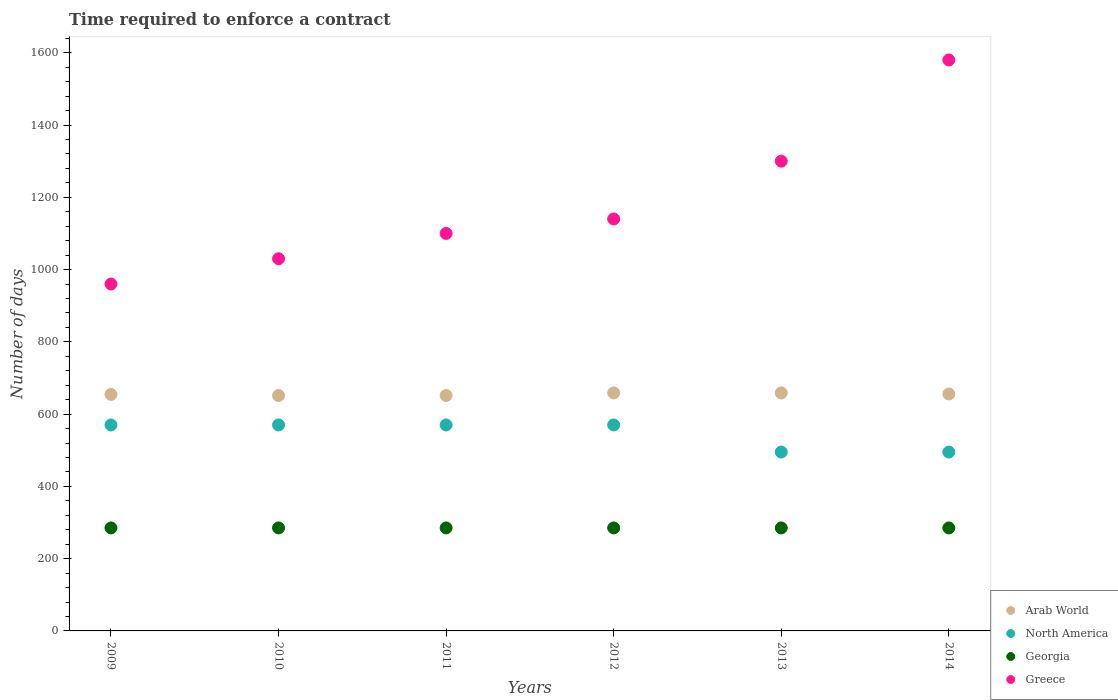What is the number of days required to enforce a contract in Greece in 2011?
Your answer should be very brief. 1100. Across all years, what is the maximum number of days required to enforce a contract in Georgia?
Keep it short and to the point. 285. Across all years, what is the minimum number of days required to enforce a contract in Greece?
Provide a succinct answer. 960. In which year was the number of days required to enforce a contract in Greece maximum?
Provide a short and direct response. 2014. What is the total number of days required to enforce a contract in Georgia in the graph?
Your response must be concise. 1710. What is the difference between the number of days required to enforce a contract in North America in 2011 and that in 2012?
Provide a succinct answer. 0. What is the difference between the number of days required to enforce a contract in Georgia in 2014 and the number of days required to enforce a contract in North America in 2010?
Your answer should be very brief. -285. What is the average number of days required to enforce a contract in Georgia per year?
Offer a very short reply. 285. In the year 2013, what is the difference between the number of days required to enforce a contract in Arab World and number of days required to enforce a contract in North America?
Make the answer very short. 163.62. What is the ratio of the number of days required to enforce a contract in Georgia in 2011 to that in 2013?
Your response must be concise. 1. Is the number of days required to enforce a contract in North America in 2009 less than that in 2013?
Make the answer very short. No. Is the difference between the number of days required to enforce a contract in Arab World in 2009 and 2011 greater than the difference between the number of days required to enforce a contract in North America in 2009 and 2011?
Ensure brevity in your answer.  Yes. What is the difference between the highest and the second highest number of days required to enforce a contract in Georgia?
Your answer should be very brief. 0. What is the difference between the highest and the lowest number of days required to enforce a contract in Greece?
Offer a very short reply. 620. Is the sum of the number of days required to enforce a contract in Georgia in 2009 and 2013 greater than the maximum number of days required to enforce a contract in Greece across all years?
Keep it short and to the point. No. Is it the case that in every year, the sum of the number of days required to enforce a contract in Greece and number of days required to enforce a contract in Arab World  is greater than the sum of number of days required to enforce a contract in North America and number of days required to enforce a contract in Georgia?
Your answer should be very brief. Yes. Is it the case that in every year, the sum of the number of days required to enforce a contract in Georgia and number of days required to enforce a contract in North America  is greater than the number of days required to enforce a contract in Arab World?
Keep it short and to the point. Yes. How many years are there in the graph?
Keep it short and to the point. 6. What is the difference between two consecutive major ticks on the Y-axis?
Keep it short and to the point. 200. Are the values on the major ticks of Y-axis written in scientific E-notation?
Give a very brief answer. No. Does the graph contain grids?
Give a very brief answer. No. Where does the legend appear in the graph?
Make the answer very short. Bottom right. How many legend labels are there?
Give a very brief answer. 4. What is the title of the graph?
Give a very brief answer. Time required to enforce a contract. What is the label or title of the X-axis?
Offer a terse response. Years. What is the label or title of the Y-axis?
Your answer should be compact. Number of days. What is the Number of days of Arab World in 2009?
Offer a terse response. 654.45. What is the Number of days of North America in 2009?
Give a very brief answer. 570. What is the Number of days in Georgia in 2009?
Provide a succinct answer. 285. What is the Number of days of Greece in 2009?
Make the answer very short. 960. What is the Number of days in Arab World in 2010?
Provide a short and direct response. 651.45. What is the Number of days of North America in 2010?
Keep it short and to the point. 570. What is the Number of days of Georgia in 2010?
Provide a short and direct response. 285. What is the Number of days of Greece in 2010?
Ensure brevity in your answer.  1030. What is the Number of days of Arab World in 2011?
Your response must be concise. 651.45. What is the Number of days of North America in 2011?
Give a very brief answer. 570. What is the Number of days of Georgia in 2011?
Offer a very short reply. 285. What is the Number of days of Greece in 2011?
Provide a short and direct response. 1100. What is the Number of days of Arab World in 2012?
Provide a succinct answer. 658.62. What is the Number of days of North America in 2012?
Provide a short and direct response. 570. What is the Number of days of Georgia in 2012?
Your answer should be compact. 285. What is the Number of days in Greece in 2012?
Your answer should be compact. 1140. What is the Number of days in Arab World in 2013?
Your answer should be compact. 658.62. What is the Number of days of North America in 2013?
Give a very brief answer. 495. What is the Number of days in Georgia in 2013?
Keep it short and to the point. 285. What is the Number of days of Greece in 2013?
Offer a very short reply. 1300. What is the Number of days in Arab World in 2014?
Ensure brevity in your answer.  655.76. What is the Number of days in North America in 2014?
Provide a short and direct response. 495. What is the Number of days in Georgia in 2014?
Your answer should be very brief. 285. What is the Number of days in Greece in 2014?
Offer a very short reply. 1580. Across all years, what is the maximum Number of days of Arab World?
Provide a succinct answer. 658.62. Across all years, what is the maximum Number of days of North America?
Your response must be concise. 570. Across all years, what is the maximum Number of days of Georgia?
Your answer should be compact. 285. Across all years, what is the maximum Number of days of Greece?
Ensure brevity in your answer.  1580. Across all years, what is the minimum Number of days in Arab World?
Offer a terse response. 651.45. Across all years, what is the minimum Number of days of North America?
Give a very brief answer. 495. Across all years, what is the minimum Number of days of Georgia?
Offer a terse response. 285. Across all years, what is the minimum Number of days in Greece?
Offer a very short reply. 960. What is the total Number of days in Arab World in the graph?
Your response must be concise. 3930.35. What is the total Number of days in North America in the graph?
Your answer should be very brief. 3270. What is the total Number of days in Georgia in the graph?
Your answer should be compact. 1710. What is the total Number of days in Greece in the graph?
Your answer should be compact. 7110. What is the difference between the Number of days of Georgia in 2009 and that in 2010?
Ensure brevity in your answer.  0. What is the difference between the Number of days in Greece in 2009 and that in 2010?
Keep it short and to the point. -70. What is the difference between the Number of days in Arab World in 2009 and that in 2011?
Offer a terse response. 3. What is the difference between the Number of days in North America in 2009 and that in 2011?
Your answer should be compact. 0. What is the difference between the Number of days of Greece in 2009 and that in 2011?
Provide a succinct answer. -140. What is the difference between the Number of days of Arab World in 2009 and that in 2012?
Provide a short and direct response. -4.17. What is the difference between the Number of days of North America in 2009 and that in 2012?
Provide a short and direct response. 0. What is the difference between the Number of days in Georgia in 2009 and that in 2012?
Provide a succinct answer. 0. What is the difference between the Number of days of Greece in 2009 and that in 2012?
Your answer should be very brief. -180. What is the difference between the Number of days in Arab World in 2009 and that in 2013?
Your response must be concise. -4.17. What is the difference between the Number of days in Georgia in 2009 and that in 2013?
Your answer should be compact. 0. What is the difference between the Number of days of Greece in 2009 and that in 2013?
Give a very brief answer. -340. What is the difference between the Number of days of Arab World in 2009 and that in 2014?
Your answer should be compact. -1.31. What is the difference between the Number of days in Georgia in 2009 and that in 2014?
Provide a succinct answer. 0. What is the difference between the Number of days in Greece in 2009 and that in 2014?
Make the answer very short. -620. What is the difference between the Number of days of Greece in 2010 and that in 2011?
Your response must be concise. -70. What is the difference between the Number of days of Arab World in 2010 and that in 2012?
Offer a terse response. -7.17. What is the difference between the Number of days of Georgia in 2010 and that in 2012?
Your response must be concise. 0. What is the difference between the Number of days of Greece in 2010 and that in 2012?
Provide a short and direct response. -110. What is the difference between the Number of days in Arab World in 2010 and that in 2013?
Your answer should be very brief. -7.17. What is the difference between the Number of days of North America in 2010 and that in 2013?
Make the answer very short. 75. What is the difference between the Number of days of Greece in 2010 and that in 2013?
Your response must be concise. -270. What is the difference between the Number of days in Arab World in 2010 and that in 2014?
Your answer should be very brief. -4.31. What is the difference between the Number of days in North America in 2010 and that in 2014?
Keep it short and to the point. 75. What is the difference between the Number of days of Greece in 2010 and that in 2014?
Ensure brevity in your answer.  -550. What is the difference between the Number of days in Arab World in 2011 and that in 2012?
Keep it short and to the point. -7.17. What is the difference between the Number of days in Greece in 2011 and that in 2012?
Offer a terse response. -40. What is the difference between the Number of days of Arab World in 2011 and that in 2013?
Give a very brief answer. -7.17. What is the difference between the Number of days of North America in 2011 and that in 2013?
Keep it short and to the point. 75. What is the difference between the Number of days of Georgia in 2011 and that in 2013?
Your answer should be compact. 0. What is the difference between the Number of days in Greece in 2011 and that in 2013?
Provide a short and direct response. -200. What is the difference between the Number of days of Arab World in 2011 and that in 2014?
Provide a short and direct response. -4.31. What is the difference between the Number of days of Greece in 2011 and that in 2014?
Keep it short and to the point. -480. What is the difference between the Number of days of North America in 2012 and that in 2013?
Keep it short and to the point. 75. What is the difference between the Number of days of Greece in 2012 and that in 2013?
Provide a succinct answer. -160. What is the difference between the Number of days of Arab World in 2012 and that in 2014?
Provide a succinct answer. 2.86. What is the difference between the Number of days of North America in 2012 and that in 2014?
Provide a short and direct response. 75. What is the difference between the Number of days of Greece in 2012 and that in 2014?
Offer a very short reply. -440. What is the difference between the Number of days in Arab World in 2013 and that in 2014?
Offer a very short reply. 2.86. What is the difference between the Number of days of North America in 2013 and that in 2014?
Ensure brevity in your answer.  0. What is the difference between the Number of days of Georgia in 2013 and that in 2014?
Make the answer very short. 0. What is the difference between the Number of days in Greece in 2013 and that in 2014?
Give a very brief answer. -280. What is the difference between the Number of days of Arab World in 2009 and the Number of days of North America in 2010?
Keep it short and to the point. 84.45. What is the difference between the Number of days in Arab World in 2009 and the Number of days in Georgia in 2010?
Offer a terse response. 369.45. What is the difference between the Number of days in Arab World in 2009 and the Number of days in Greece in 2010?
Make the answer very short. -375.55. What is the difference between the Number of days in North America in 2009 and the Number of days in Georgia in 2010?
Your response must be concise. 285. What is the difference between the Number of days of North America in 2009 and the Number of days of Greece in 2010?
Your response must be concise. -460. What is the difference between the Number of days in Georgia in 2009 and the Number of days in Greece in 2010?
Offer a terse response. -745. What is the difference between the Number of days in Arab World in 2009 and the Number of days in North America in 2011?
Give a very brief answer. 84.45. What is the difference between the Number of days in Arab World in 2009 and the Number of days in Georgia in 2011?
Your answer should be very brief. 369.45. What is the difference between the Number of days of Arab World in 2009 and the Number of days of Greece in 2011?
Provide a short and direct response. -445.55. What is the difference between the Number of days of North America in 2009 and the Number of days of Georgia in 2011?
Offer a very short reply. 285. What is the difference between the Number of days in North America in 2009 and the Number of days in Greece in 2011?
Your answer should be compact. -530. What is the difference between the Number of days of Georgia in 2009 and the Number of days of Greece in 2011?
Offer a very short reply. -815. What is the difference between the Number of days in Arab World in 2009 and the Number of days in North America in 2012?
Your answer should be compact. 84.45. What is the difference between the Number of days of Arab World in 2009 and the Number of days of Georgia in 2012?
Make the answer very short. 369.45. What is the difference between the Number of days in Arab World in 2009 and the Number of days in Greece in 2012?
Ensure brevity in your answer.  -485.55. What is the difference between the Number of days of North America in 2009 and the Number of days of Georgia in 2012?
Offer a very short reply. 285. What is the difference between the Number of days of North America in 2009 and the Number of days of Greece in 2012?
Ensure brevity in your answer.  -570. What is the difference between the Number of days of Georgia in 2009 and the Number of days of Greece in 2012?
Your answer should be very brief. -855. What is the difference between the Number of days in Arab World in 2009 and the Number of days in North America in 2013?
Offer a very short reply. 159.45. What is the difference between the Number of days of Arab World in 2009 and the Number of days of Georgia in 2013?
Provide a short and direct response. 369.45. What is the difference between the Number of days of Arab World in 2009 and the Number of days of Greece in 2013?
Offer a terse response. -645.55. What is the difference between the Number of days in North America in 2009 and the Number of days in Georgia in 2013?
Your answer should be very brief. 285. What is the difference between the Number of days in North America in 2009 and the Number of days in Greece in 2013?
Provide a succinct answer. -730. What is the difference between the Number of days of Georgia in 2009 and the Number of days of Greece in 2013?
Offer a terse response. -1015. What is the difference between the Number of days in Arab World in 2009 and the Number of days in North America in 2014?
Offer a very short reply. 159.45. What is the difference between the Number of days in Arab World in 2009 and the Number of days in Georgia in 2014?
Keep it short and to the point. 369.45. What is the difference between the Number of days of Arab World in 2009 and the Number of days of Greece in 2014?
Provide a short and direct response. -925.55. What is the difference between the Number of days of North America in 2009 and the Number of days of Georgia in 2014?
Offer a terse response. 285. What is the difference between the Number of days in North America in 2009 and the Number of days in Greece in 2014?
Your answer should be compact. -1010. What is the difference between the Number of days in Georgia in 2009 and the Number of days in Greece in 2014?
Your answer should be compact. -1295. What is the difference between the Number of days of Arab World in 2010 and the Number of days of North America in 2011?
Offer a very short reply. 81.45. What is the difference between the Number of days in Arab World in 2010 and the Number of days in Georgia in 2011?
Keep it short and to the point. 366.45. What is the difference between the Number of days in Arab World in 2010 and the Number of days in Greece in 2011?
Offer a terse response. -448.55. What is the difference between the Number of days of North America in 2010 and the Number of days of Georgia in 2011?
Give a very brief answer. 285. What is the difference between the Number of days in North America in 2010 and the Number of days in Greece in 2011?
Your answer should be compact. -530. What is the difference between the Number of days in Georgia in 2010 and the Number of days in Greece in 2011?
Your response must be concise. -815. What is the difference between the Number of days in Arab World in 2010 and the Number of days in North America in 2012?
Your answer should be very brief. 81.45. What is the difference between the Number of days of Arab World in 2010 and the Number of days of Georgia in 2012?
Your response must be concise. 366.45. What is the difference between the Number of days in Arab World in 2010 and the Number of days in Greece in 2012?
Give a very brief answer. -488.55. What is the difference between the Number of days of North America in 2010 and the Number of days of Georgia in 2012?
Offer a very short reply. 285. What is the difference between the Number of days of North America in 2010 and the Number of days of Greece in 2012?
Keep it short and to the point. -570. What is the difference between the Number of days in Georgia in 2010 and the Number of days in Greece in 2012?
Your answer should be compact. -855. What is the difference between the Number of days of Arab World in 2010 and the Number of days of North America in 2013?
Give a very brief answer. 156.45. What is the difference between the Number of days in Arab World in 2010 and the Number of days in Georgia in 2013?
Provide a succinct answer. 366.45. What is the difference between the Number of days in Arab World in 2010 and the Number of days in Greece in 2013?
Provide a succinct answer. -648.55. What is the difference between the Number of days of North America in 2010 and the Number of days of Georgia in 2013?
Offer a terse response. 285. What is the difference between the Number of days in North America in 2010 and the Number of days in Greece in 2013?
Keep it short and to the point. -730. What is the difference between the Number of days in Georgia in 2010 and the Number of days in Greece in 2013?
Your answer should be compact. -1015. What is the difference between the Number of days in Arab World in 2010 and the Number of days in North America in 2014?
Offer a terse response. 156.45. What is the difference between the Number of days of Arab World in 2010 and the Number of days of Georgia in 2014?
Your answer should be compact. 366.45. What is the difference between the Number of days in Arab World in 2010 and the Number of days in Greece in 2014?
Keep it short and to the point. -928.55. What is the difference between the Number of days in North America in 2010 and the Number of days in Georgia in 2014?
Give a very brief answer. 285. What is the difference between the Number of days in North America in 2010 and the Number of days in Greece in 2014?
Offer a terse response. -1010. What is the difference between the Number of days of Georgia in 2010 and the Number of days of Greece in 2014?
Keep it short and to the point. -1295. What is the difference between the Number of days in Arab World in 2011 and the Number of days in North America in 2012?
Your answer should be very brief. 81.45. What is the difference between the Number of days in Arab World in 2011 and the Number of days in Georgia in 2012?
Offer a very short reply. 366.45. What is the difference between the Number of days in Arab World in 2011 and the Number of days in Greece in 2012?
Your answer should be compact. -488.55. What is the difference between the Number of days of North America in 2011 and the Number of days of Georgia in 2012?
Your answer should be very brief. 285. What is the difference between the Number of days in North America in 2011 and the Number of days in Greece in 2012?
Ensure brevity in your answer.  -570. What is the difference between the Number of days in Georgia in 2011 and the Number of days in Greece in 2012?
Provide a short and direct response. -855. What is the difference between the Number of days in Arab World in 2011 and the Number of days in North America in 2013?
Make the answer very short. 156.45. What is the difference between the Number of days in Arab World in 2011 and the Number of days in Georgia in 2013?
Your response must be concise. 366.45. What is the difference between the Number of days in Arab World in 2011 and the Number of days in Greece in 2013?
Your answer should be very brief. -648.55. What is the difference between the Number of days of North America in 2011 and the Number of days of Georgia in 2013?
Your answer should be compact. 285. What is the difference between the Number of days of North America in 2011 and the Number of days of Greece in 2013?
Provide a short and direct response. -730. What is the difference between the Number of days in Georgia in 2011 and the Number of days in Greece in 2013?
Ensure brevity in your answer.  -1015. What is the difference between the Number of days in Arab World in 2011 and the Number of days in North America in 2014?
Make the answer very short. 156.45. What is the difference between the Number of days of Arab World in 2011 and the Number of days of Georgia in 2014?
Provide a short and direct response. 366.45. What is the difference between the Number of days of Arab World in 2011 and the Number of days of Greece in 2014?
Offer a terse response. -928.55. What is the difference between the Number of days of North America in 2011 and the Number of days of Georgia in 2014?
Keep it short and to the point. 285. What is the difference between the Number of days of North America in 2011 and the Number of days of Greece in 2014?
Your response must be concise. -1010. What is the difference between the Number of days of Georgia in 2011 and the Number of days of Greece in 2014?
Ensure brevity in your answer.  -1295. What is the difference between the Number of days of Arab World in 2012 and the Number of days of North America in 2013?
Give a very brief answer. 163.62. What is the difference between the Number of days of Arab World in 2012 and the Number of days of Georgia in 2013?
Your response must be concise. 373.62. What is the difference between the Number of days of Arab World in 2012 and the Number of days of Greece in 2013?
Your response must be concise. -641.38. What is the difference between the Number of days in North America in 2012 and the Number of days in Georgia in 2013?
Give a very brief answer. 285. What is the difference between the Number of days of North America in 2012 and the Number of days of Greece in 2013?
Offer a terse response. -730. What is the difference between the Number of days in Georgia in 2012 and the Number of days in Greece in 2013?
Offer a terse response. -1015. What is the difference between the Number of days of Arab World in 2012 and the Number of days of North America in 2014?
Offer a terse response. 163.62. What is the difference between the Number of days of Arab World in 2012 and the Number of days of Georgia in 2014?
Provide a succinct answer. 373.62. What is the difference between the Number of days of Arab World in 2012 and the Number of days of Greece in 2014?
Offer a terse response. -921.38. What is the difference between the Number of days of North America in 2012 and the Number of days of Georgia in 2014?
Ensure brevity in your answer.  285. What is the difference between the Number of days in North America in 2012 and the Number of days in Greece in 2014?
Your response must be concise. -1010. What is the difference between the Number of days of Georgia in 2012 and the Number of days of Greece in 2014?
Your response must be concise. -1295. What is the difference between the Number of days in Arab World in 2013 and the Number of days in North America in 2014?
Ensure brevity in your answer.  163.62. What is the difference between the Number of days in Arab World in 2013 and the Number of days in Georgia in 2014?
Your response must be concise. 373.62. What is the difference between the Number of days of Arab World in 2013 and the Number of days of Greece in 2014?
Provide a succinct answer. -921.38. What is the difference between the Number of days of North America in 2013 and the Number of days of Georgia in 2014?
Offer a terse response. 210. What is the difference between the Number of days in North America in 2013 and the Number of days in Greece in 2014?
Offer a terse response. -1085. What is the difference between the Number of days of Georgia in 2013 and the Number of days of Greece in 2014?
Provide a succinct answer. -1295. What is the average Number of days of Arab World per year?
Provide a short and direct response. 655.06. What is the average Number of days of North America per year?
Make the answer very short. 545. What is the average Number of days of Georgia per year?
Your answer should be compact. 285. What is the average Number of days in Greece per year?
Provide a succinct answer. 1185. In the year 2009, what is the difference between the Number of days in Arab World and Number of days in North America?
Your answer should be compact. 84.45. In the year 2009, what is the difference between the Number of days in Arab World and Number of days in Georgia?
Your answer should be compact. 369.45. In the year 2009, what is the difference between the Number of days in Arab World and Number of days in Greece?
Provide a short and direct response. -305.55. In the year 2009, what is the difference between the Number of days of North America and Number of days of Georgia?
Ensure brevity in your answer.  285. In the year 2009, what is the difference between the Number of days of North America and Number of days of Greece?
Your response must be concise. -390. In the year 2009, what is the difference between the Number of days of Georgia and Number of days of Greece?
Ensure brevity in your answer.  -675. In the year 2010, what is the difference between the Number of days in Arab World and Number of days in North America?
Provide a short and direct response. 81.45. In the year 2010, what is the difference between the Number of days in Arab World and Number of days in Georgia?
Provide a short and direct response. 366.45. In the year 2010, what is the difference between the Number of days of Arab World and Number of days of Greece?
Give a very brief answer. -378.55. In the year 2010, what is the difference between the Number of days in North America and Number of days in Georgia?
Provide a short and direct response. 285. In the year 2010, what is the difference between the Number of days of North America and Number of days of Greece?
Provide a succinct answer. -460. In the year 2010, what is the difference between the Number of days in Georgia and Number of days in Greece?
Ensure brevity in your answer.  -745. In the year 2011, what is the difference between the Number of days in Arab World and Number of days in North America?
Make the answer very short. 81.45. In the year 2011, what is the difference between the Number of days of Arab World and Number of days of Georgia?
Offer a terse response. 366.45. In the year 2011, what is the difference between the Number of days in Arab World and Number of days in Greece?
Give a very brief answer. -448.55. In the year 2011, what is the difference between the Number of days of North America and Number of days of Georgia?
Offer a very short reply. 285. In the year 2011, what is the difference between the Number of days in North America and Number of days in Greece?
Your response must be concise. -530. In the year 2011, what is the difference between the Number of days of Georgia and Number of days of Greece?
Keep it short and to the point. -815. In the year 2012, what is the difference between the Number of days in Arab World and Number of days in North America?
Your answer should be compact. 88.62. In the year 2012, what is the difference between the Number of days in Arab World and Number of days in Georgia?
Your answer should be compact. 373.62. In the year 2012, what is the difference between the Number of days in Arab World and Number of days in Greece?
Keep it short and to the point. -481.38. In the year 2012, what is the difference between the Number of days in North America and Number of days in Georgia?
Provide a succinct answer. 285. In the year 2012, what is the difference between the Number of days in North America and Number of days in Greece?
Provide a short and direct response. -570. In the year 2012, what is the difference between the Number of days in Georgia and Number of days in Greece?
Your answer should be compact. -855. In the year 2013, what is the difference between the Number of days in Arab World and Number of days in North America?
Give a very brief answer. 163.62. In the year 2013, what is the difference between the Number of days in Arab World and Number of days in Georgia?
Make the answer very short. 373.62. In the year 2013, what is the difference between the Number of days in Arab World and Number of days in Greece?
Your response must be concise. -641.38. In the year 2013, what is the difference between the Number of days in North America and Number of days in Georgia?
Give a very brief answer. 210. In the year 2013, what is the difference between the Number of days of North America and Number of days of Greece?
Provide a short and direct response. -805. In the year 2013, what is the difference between the Number of days of Georgia and Number of days of Greece?
Give a very brief answer. -1015. In the year 2014, what is the difference between the Number of days in Arab World and Number of days in North America?
Your response must be concise. 160.76. In the year 2014, what is the difference between the Number of days of Arab World and Number of days of Georgia?
Keep it short and to the point. 370.76. In the year 2014, what is the difference between the Number of days in Arab World and Number of days in Greece?
Provide a succinct answer. -924.24. In the year 2014, what is the difference between the Number of days in North America and Number of days in Georgia?
Provide a short and direct response. 210. In the year 2014, what is the difference between the Number of days of North America and Number of days of Greece?
Offer a very short reply. -1085. In the year 2014, what is the difference between the Number of days of Georgia and Number of days of Greece?
Keep it short and to the point. -1295. What is the ratio of the Number of days in Arab World in 2009 to that in 2010?
Your answer should be compact. 1. What is the ratio of the Number of days of North America in 2009 to that in 2010?
Make the answer very short. 1. What is the ratio of the Number of days of Greece in 2009 to that in 2010?
Ensure brevity in your answer.  0.93. What is the ratio of the Number of days of Greece in 2009 to that in 2011?
Your answer should be very brief. 0.87. What is the ratio of the Number of days of North America in 2009 to that in 2012?
Give a very brief answer. 1. What is the ratio of the Number of days of Greece in 2009 to that in 2012?
Provide a succinct answer. 0.84. What is the ratio of the Number of days in North America in 2009 to that in 2013?
Your response must be concise. 1.15. What is the ratio of the Number of days in Georgia in 2009 to that in 2013?
Provide a short and direct response. 1. What is the ratio of the Number of days of Greece in 2009 to that in 2013?
Your answer should be very brief. 0.74. What is the ratio of the Number of days of Arab World in 2009 to that in 2014?
Ensure brevity in your answer.  1. What is the ratio of the Number of days of North America in 2009 to that in 2014?
Keep it short and to the point. 1.15. What is the ratio of the Number of days of Georgia in 2009 to that in 2014?
Your answer should be compact. 1. What is the ratio of the Number of days in Greece in 2009 to that in 2014?
Keep it short and to the point. 0.61. What is the ratio of the Number of days in Arab World in 2010 to that in 2011?
Ensure brevity in your answer.  1. What is the ratio of the Number of days in North America in 2010 to that in 2011?
Provide a short and direct response. 1. What is the ratio of the Number of days of Georgia in 2010 to that in 2011?
Offer a very short reply. 1. What is the ratio of the Number of days in Greece in 2010 to that in 2011?
Your answer should be very brief. 0.94. What is the ratio of the Number of days of Greece in 2010 to that in 2012?
Ensure brevity in your answer.  0.9. What is the ratio of the Number of days in Arab World in 2010 to that in 2013?
Ensure brevity in your answer.  0.99. What is the ratio of the Number of days in North America in 2010 to that in 2013?
Your response must be concise. 1.15. What is the ratio of the Number of days of Georgia in 2010 to that in 2013?
Keep it short and to the point. 1. What is the ratio of the Number of days in Greece in 2010 to that in 2013?
Provide a succinct answer. 0.79. What is the ratio of the Number of days of Arab World in 2010 to that in 2014?
Keep it short and to the point. 0.99. What is the ratio of the Number of days of North America in 2010 to that in 2014?
Provide a short and direct response. 1.15. What is the ratio of the Number of days in Georgia in 2010 to that in 2014?
Make the answer very short. 1. What is the ratio of the Number of days in Greece in 2010 to that in 2014?
Offer a terse response. 0.65. What is the ratio of the Number of days of North America in 2011 to that in 2012?
Your answer should be compact. 1. What is the ratio of the Number of days of Greece in 2011 to that in 2012?
Provide a succinct answer. 0.96. What is the ratio of the Number of days of Arab World in 2011 to that in 2013?
Your answer should be compact. 0.99. What is the ratio of the Number of days of North America in 2011 to that in 2013?
Provide a short and direct response. 1.15. What is the ratio of the Number of days of Georgia in 2011 to that in 2013?
Keep it short and to the point. 1. What is the ratio of the Number of days in Greece in 2011 to that in 2013?
Offer a terse response. 0.85. What is the ratio of the Number of days of Arab World in 2011 to that in 2014?
Make the answer very short. 0.99. What is the ratio of the Number of days of North America in 2011 to that in 2014?
Keep it short and to the point. 1.15. What is the ratio of the Number of days of Georgia in 2011 to that in 2014?
Offer a terse response. 1. What is the ratio of the Number of days of Greece in 2011 to that in 2014?
Keep it short and to the point. 0.7. What is the ratio of the Number of days in North America in 2012 to that in 2013?
Give a very brief answer. 1.15. What is the ratio of the Number of days of Greece in 2012 to that in 2013?
Keep it short and to the point. 0.88. What is the ratio of the Number of days in North America in 2012 to that in 2014?
Your response must be concise. 1.15. What is the ratio of the Number of days of Georgia in 2012 to that in 2014?
Offer a terse response. 1. What is the ratio of the Number of days in Greece in 2012 to that in 2014?
Offer a very short reply. 0.72. What is the ratio of the Number of days in Georgia in 2013 to that in 2014?
Your answer should be very brief. 1. What is the ratio of the Number of days in Greece in 2013 to that in 2014?
Give a very brief answer. 0.82. What is the difference between the highest and the second highest Number of days in Greece?
Provide a succinct answer. 280. What is the difference between the highest and the lowest Number of days in Arab World?
Provide a succinct answer. 7.17. What is the difference between the highest and the lowest Number of days of Georgia?
Offer a terse response. 0. What is the difference between the highest and the lowest Number of days of Greece?
Provide a short and direct response. 620. 